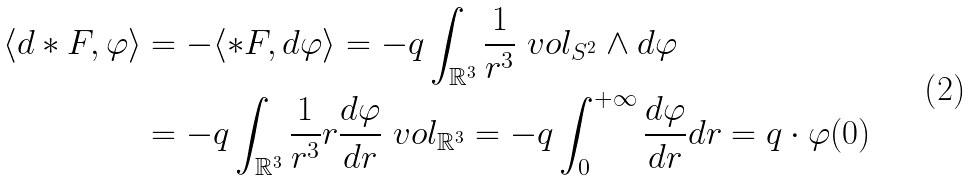Convert formula to latex. <formula><loc_0><loc_0><loc_500><loc_500>\langle d * F , \varphi \rangle & = - \langle * F , d \varphi \rangle = - q \int _ { \mathbb { R } ^ { 3 } } \frac { 1 } { r ^ { 3 } } \ v o l _ { S ^ { 2 } } \wedge d \varphi \\ & = - q \int _ { \mathbb { R } ^ { 3 } } \frac { 1 } { r ^ { 3 } } r \frac { d \varphi } { d r } \ v o l _ { \mathbb { R } ^ { 3 } } = - q \int _ { 0 } ^ { + \infty } \frac { d \varphi } { d r } d r = q \cdot \varphi ( 0 )</formula> 